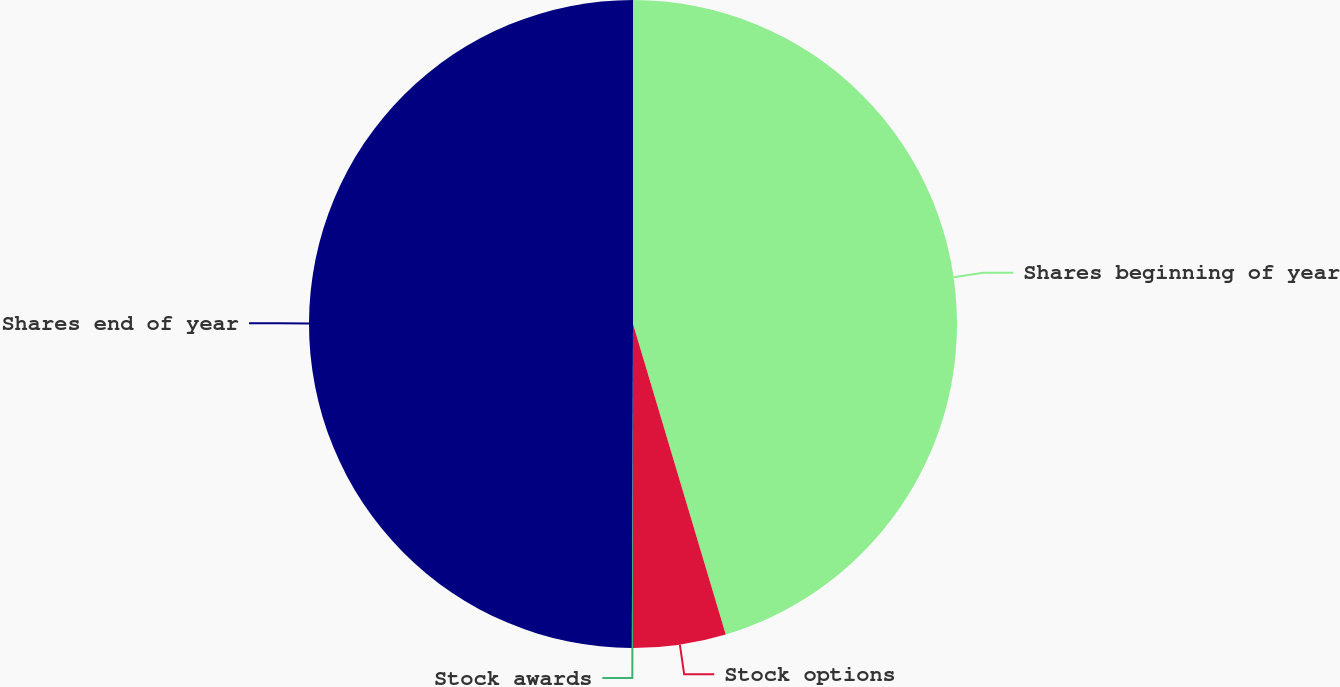Convert chart to OTSL. <chart><loc_0><loc_0><loc_500><loc_500><pie_chart><fcel>Shares beginning of year<fcel>Stock options<fcel>Stock awards<fcel>Shares end of year<nl><fcel>45.38%<fcel>4.62%<fcel>0.06%<fcel>49.94%<nl></chart> 